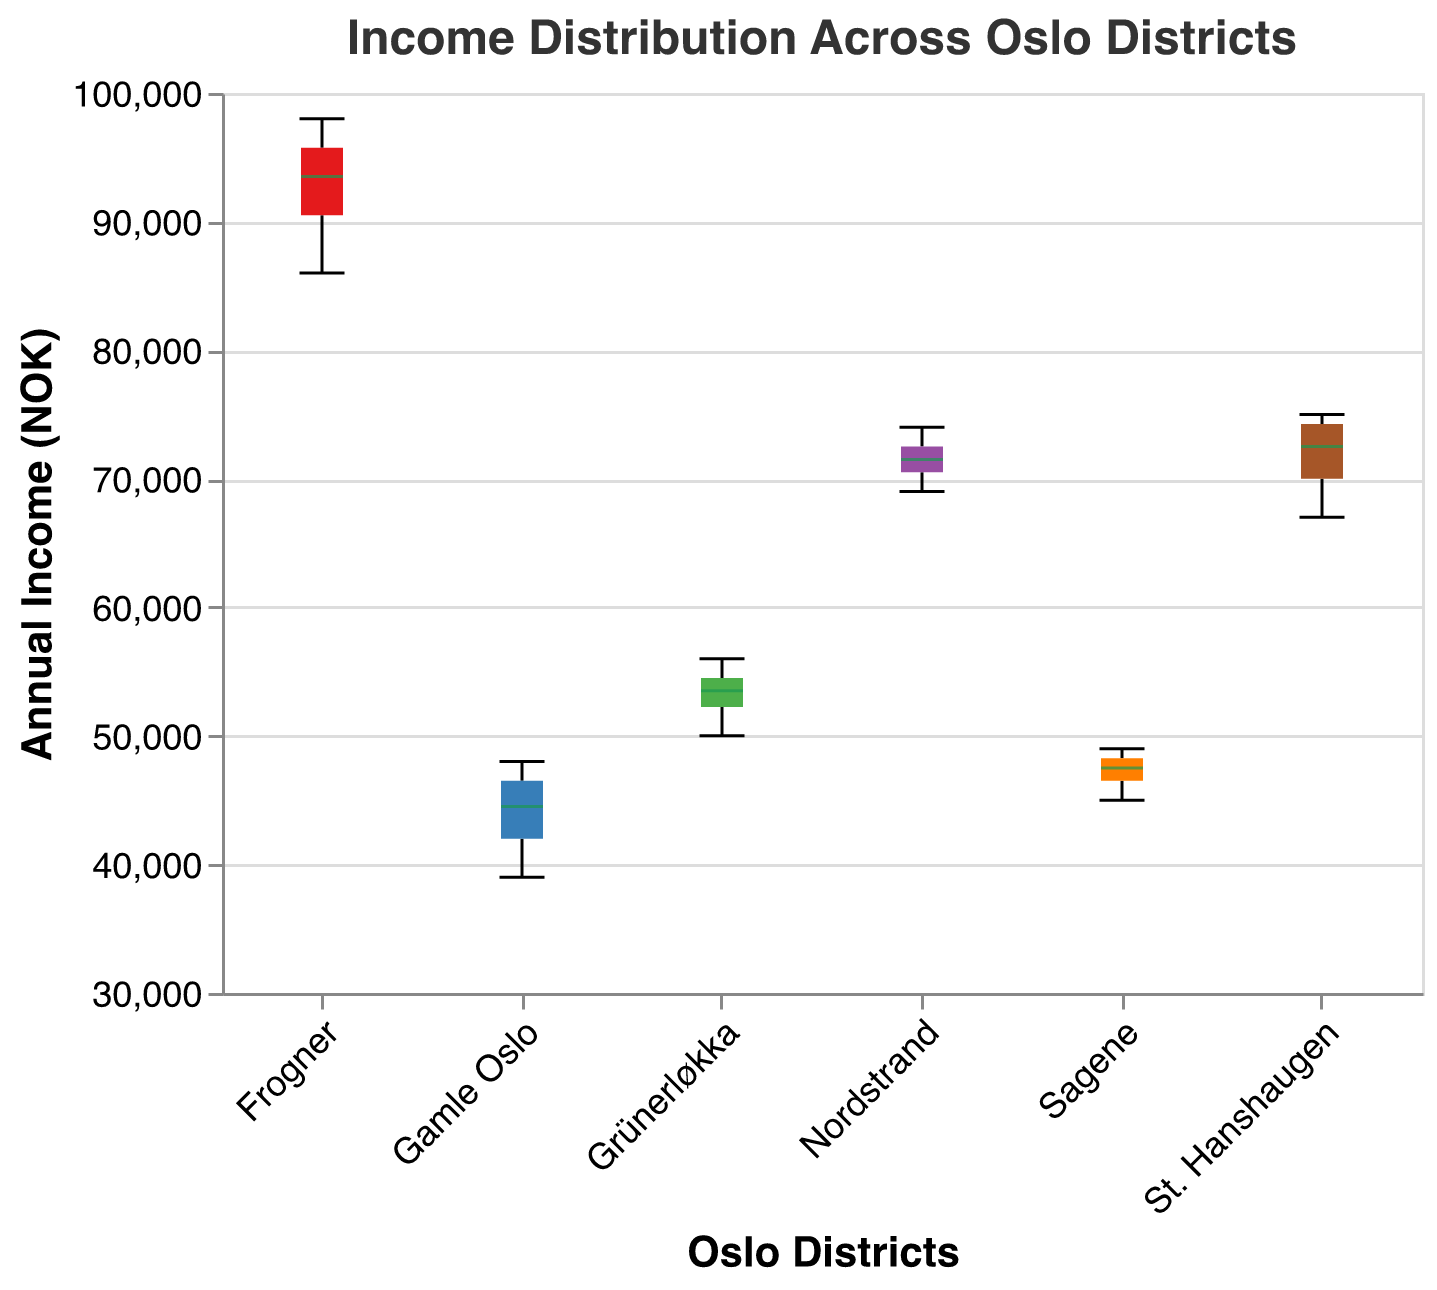What's the range of income in Frogner? The range of income is calculated by finding the difference between the maximum and minimum values in the district of Frogner. The maximum income is 98,000 NOK and the minimum income is 86,000 NOK. So, the range is 98,000 - 86,000 = 12,000 NOK.
Answer: 12,000 NOK Which district has the highest median income? To find the district with the highest median income, look for the middle value in each district’s box plot. Frogner's median income line is visibly higher than those of the other districts.
Answer: Frogner How many districts have a median income above 50,000 NOK? To determine how many districts have a median income above 50,000 NOK, look for the median lines (inside the boxes) in each box plot and count the number of lines above the 50,000 NOK mark. There are four such districts: Frogner, St. Hanshaugen, Nordstrand, and Grünerløkka.
Answer: 4 Which district has the most variability in income? The district with the most variability in income will have the longest box plot. Frogner has the longest box plot, indicating the greatest variability.
Answer: Frogner What is the interquartile range (IQR) for income in Nordstrand? To find the IQR, identify the length of the box (which represents the range between the first quartile (Q1) and the third quartile (Q3)). For Nordstrand, Q1 is about 69,000 NOK and Q3 is about 72,000 NOK. Therefore, IQR = 72,000 - 69,000 = 3,000 NOK.
Answer: 3,000 NOK Which district has the lowest median income? To find the district with the lowest median income, look for the district with the lowest median line within its box plot. Gamle Oslo has the lowest median income.
Answer: Gamle Oslo How does the median income in Grünerløkka compare to Sagene? Compare the median lines within each box plot for Grünerløkka and Sagene. Grünerløkka's median income is higher than Sagene's.
Answer: Grünerløkka's median is higher Is there any district where the minimum income exceeds the maximum income in another district? Compare the whiskers of each box plot (which represent the minimum and maximum values). None of the minimum incomes exceed the maximum incomes in other districts.
Answer: No What's the range of incomes in Nordstrand? The range in Nordstrand is found by subtracting the minimum income from the maximum income. The maximum income is 74,000 NOK and the minimum income is 69,000 NOK. Thus, the range is 74,000 - 69,000 = 5,000 NOK.
Answer: 5,000 NOK 